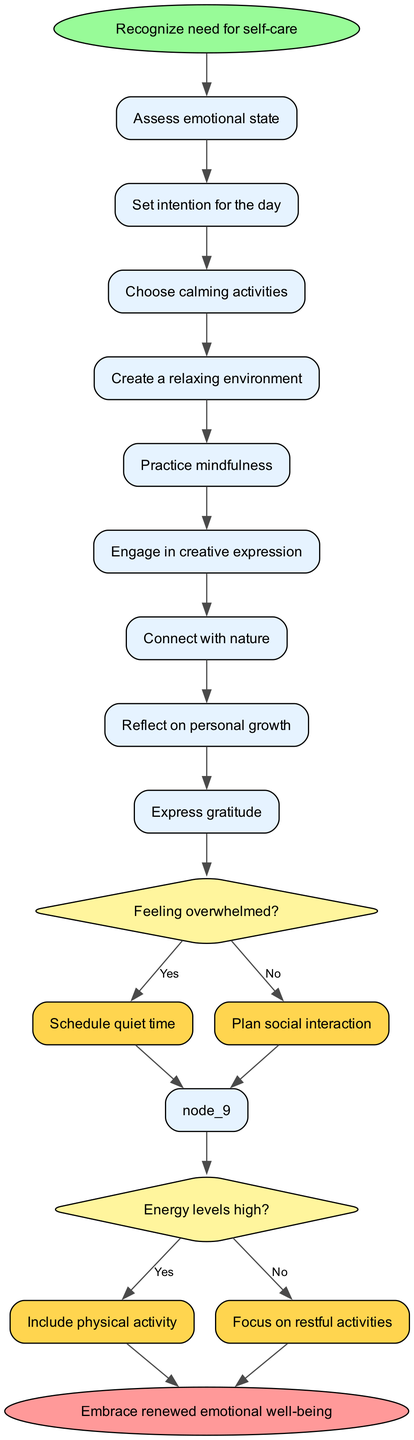What is the first node in the diagram? The diagram starts with the node labeled "Recognize need for self-care," which indicates the initial step in planning the self-care day.
Answer: Recognize need for self-care How many calming activities are listed in the nodes? There are a total of eight activities mentioned in the nodes: "Assess emotional state," "Set intention for the day," "Choose calming activities," "Create a relaxing environment," "Practice mindfulness," "Engage in creative expression," "Connect with nature," and "Reflect on personal growth."
Answer: Eight What happens if the answer to "Feeling overwhelmed?" is No? If the answer to "Feeling overwhelmed?" is No, the flow chart suggests "Plan social interaction" as the next step.
Answer: Plan social interaction What is the last node before the end of the flow chart? The last node before reaching the end of the flow chart is "Express gratitude," which leads to the conclusion.
Answer: Express gratitude What should be included if energy levels are high? If energy levels are high, the flow chart indicates that one should "Include physical activity" in the day's plan.
Answer: Include physical activity If someone feels overwhelmed and low on energy, what activity will they focus on? Following the flow chart, if they feel overwhelmed, they will schedule quiet time. Additionally, since they have low energy, they will focus on restful activities, as indicated by the decision pathways.
Answer: Focus on restful activities What is the connection between the node "Reflect on personal growth" and the decision about feeling overwhelmed? The node "Reflect on personal growth" comes before the decision about feeling overwhelmed; it serves as an emotional reflection step prior to assessing one's emotional state.
Answer: It comes before the decision What is the final outcome of the process illustrated in the flow chart? The final outcome of the flow chart is summarized in the end node labeled "Embrace renewed emotional well-being," indicating the purpose of the self-care day.
Answer: Embrace renewed emotional well-being 